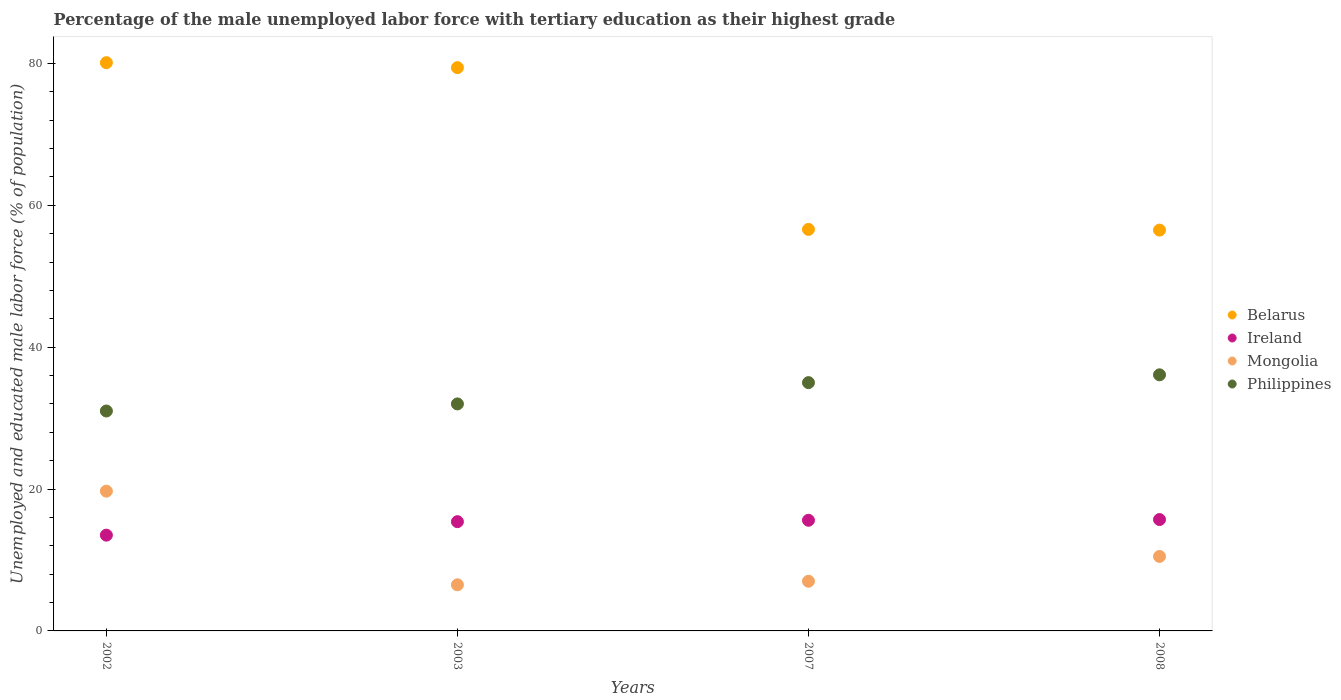Across all years, what is the maximum percentage of the unemployed male labor force with tertiary education in Ireland?
Provide a short and direct response. 15.7. Across all years, what is the minimum percentage of the unemployed male labor force with tertiary education in Belarus?
Offer a very short reply. 56.5. In which year was the percentage of the unemployed male labor force with tertiary education in Mongolia maximum?
Offer a terse response. 2002. In which year was the percentage of the unemployed male labor force with tertiary education in Ireland minimum?
Your answer should be very brief. 2002. What is the total percentage of the unemployed male labor force with tertiary education in Ireland in the graph?
Your answer should be compact. 60.2. What is the difference between the percentage of the unemployed male labor force with tertiary education in Mongolia in 2002 and that in 2003?
Offer a very short reply. 13.2. What is the difference between the percentage of the unemployed male labor force with tertiary education in Mongolia in 2002 and the percentage of the unemployed male labor force with tertiary education in Belarus in 2007?
Provide a short and direct response. -36.9. What is the average percentage of the unemployed male labor force with tertiary education in Philippines per year?
Give a very brief answer. 33.52. In the year 2003, what is the difference between the percentage of the unemployed male labor force with tertiary education in Mongolia and percentage of the unemployed male labor force with tertiary education in Philippines?
Give a very brief answer. -25.5. What is the ratio of the percentage of the unemployed male labor force with tertiary education in Belarus in 2002 to that in 2003?
Ensure brevity in your answer.  1.01. Is the percentage of the unemployed male labor force with tertiary education in Philippines in 2002 less than that in 2008?
Your answer should be very brief. Yes. Is the difference between the percentage of the unemployed male labor force with tertiary education in Mongolia in 2003 and 2007 greater than the difference between the percentage of the unemployed male labor force with tertiary education in Philippines in 2003 and 2007?
Make the answer very short. Yes. What is the difference between the highest and the second highest percentage of the unemployed male labor force with tertiary education in Belarus?
Make the answer very short. 0.7. What is the difference between the highest and the lowest percentage of the unemployed male labor force with tertiary education in Philippines?
Ensure brevity in your answer.  5.1. Is it the case that in every year, the sum of the percentage of the unemployed male labor force with tertiary education in Ireland and percentage of the unemployed male labor force with tertiary education in Belarus  is greater than the sum of percentage of the unemployed male labor force with tertiary education in Mongolia and percentage of the unemployed male labor force with tertiary education in Philippines?
Make the answer very short. Yes. Is it the case that in every year, the sum of the percentage of the unemployed male labor force with tertiary education in Philippines and percentage of the unemployed male labor force with tertiary education in Belarus  is greater than the percentage of the unemployed male labor force with tertiary education in Ireland?
Provide a short and direct response. Yes. Is the percentage of the unemployed male labor force with tertiary education in Philippines strictly greater than the percentage of the unemployed male labor force with tertiary education in Mongolia over the years?
Keep it short and to the point. Yes. Are the values on the major ticks of Y-axis written in scientific E-notation?
Keep it short and to the point. No. Does the graph contain any zero values?
Make the answer very short. No. How many legend labels are there?
Your answer should be very brief. 4. How are the legend labels stacked?
Offer a very short reply. Vertical. What is the title of the graph?
Your answer should be compact. Percentage of the male unemployed labor force with tertiary education as their highest grade. Does "Dominican Republic" appear as one of the legend labels in the graph?
Provide a succinct answer. No. What is the label or title of the Y-axis?
Your answer should be compact. Unemployed and educated male labor force (% of population). What is the Unemployed and educated male labor force (% of population) in Belarus in 2002?
Offer a terse response. 80.1. What is the Unemployed and educated male labor force (% of population) of Ireland in 2002?
Provide a short and direct response. 13.5. What is the Unemployed and educated male labor force (% of population) in Mongolia in 2002?
Provide a succinct answer. 19.7. What is the Unemployed and educated male labor force (% of population) in Belarus in 2003?
Make the answer very short. 79.4. What is the Unemployed and educated male labor force (% of population) in Ireland in 2003?
Keep it short and to the point. 15.4. What is the Unemployed and educated male labor force (% of population) of Mongolia in 2003?
Give a very brief answer. 6.5. What is the Unemployed and educated male labor force (% of population) of Philippines in 2003?
Your response must be concise. 32. What is the Unemployed and educated male labor force (% of population) in Belarus in 2007?
Provide a short and direct response. 56.6. What is the Unemployed and educated male labor force (% of population) of Ireland in 2007?
Provide a short and direct response. 15.6. What is the Unemployed and educated male labor force (% of population) of Philippines in 2007?
Give a very brief answer. 35. What is the Unemployed and educated male labor force (% of population) in Belarus in 2008?
Your response must be concise. 56.5. What is the Unemployed and educated male labor force (% of population) of Ireland in 2008?
Your answer should be very brief. 15.7. What is the Unemployed and educated male labor force (% of population) in Philippines in 2008?
Ensure brevity in your answer.  36.1. Across all years, what is the maximum Unemployed and educated male labor force (% of population) of Belarus?
Give a very brief answer. 80.1. Across all years, what is the maximum Unemployed and educated male labor force (% of population) in Ireland?
Your answer should be compact. 15.7. Across all years, what is the maximum Unemployed and educated male labor force (% of population) of Mongolia?
Make the answer very short. 19.7. Across all years, what is the maximum Unemployed and educated male labor force (% of population) of Philippines?
Give a very brief answer. 36.1. Across all years, what is the minimum Unemployed and educated male labor force (% of population) in Belarus?
Offer a terse response. 56.5. Across all years, what is the minimum Unemployed and educated male labor force (% of population) in Mongolia?
Your answer should be compact. 6.5. What is the total Unemployed and educated male labor force (% of population) in Belarus in the graph?
Keep it short and to the point. 272.6. What is the total Unemployed and educated male labor force (% of population) of Ireland in the graph?
Make the answer very short. 60.2. What is the total Unemployed and educated male labor force (% of population) of Mongolia in the graph?
Provide a short and direct response. 43.7. What is the total Unemployed and educated male labor force (% of population) of Philippines in the graph?
Make the answer very short. 134.1. What is the difference between the Unemployed and educated male labor force (% of population) of Belarus in 2002 and that in 2003?
Offer a terse response. 0.7. What is the difference between the Unemployed and educated male labor force (% of population) of Ireland in 2002 and that in 2003?
Your answer should be very brief. -1.9. What is the difference between the Unemployed and educated male labor force (% of population) in Mongolia in 2002 and that in 2003?
Ensure brevity in your answer.  13.2. What is the difference between the Unemployed and educated male labor force (% of population) in Philippines in 2002 and that in 2003?
Your answer should be very brief. -1. What is the difference between the Unemployed and educated male labor force (% of population) in Belarus in 2002 and that in 2007?
Offer a terse response. 23.5. What is the difference between the Unemployed and educated male labor force (% of population) in Ireland in 2002 and that in 2007?
Provide a succinct answer. -2.1. What is the difference between the Unemployed and educated male labor force (% of population) of Mongolia in 2002 and that in 2007?
Offer a terse response. 12.7. What is the difference between the Unemployed and educated male labor force (% of population) of Belarus in 2002 and that in 2008?
Your answer should be compact. 23.6. What is the difference between the Unemployed and educated male labor force (% of population) of Philippines in 2002 and that in 2008?
Offer a terse response. -5.1. What is the difference between the Unemployed and educated male labor force (% of population) of Belarus in 2003 and that in 2007?
Provide a succinct answer. 22.8. What is the difference between the Unemployed and educated male labor force (% of population) in Ireland in 2003 and that in 2007?
Offer a very short reply. -0.2. What is the difference between the Unemployed and educated male labor force (% of population) in Mongolia in 2003 and that in 2007?
Provide a succinct answer. -0.5. What is the difference between the Unemployed and educated male labor force (% of population) of Belarus in 2003 and that in 2008?
Your answer should be compact. 22.9. What is the difference between the Unemployed and educated male labor force (% of population) in Ireland in 2003 and that in 2008?
Ensure brevity in your answer.  -0.3. What is the difference between the Unemployed and educated male labor force (% of population) in Mongolia in 2003 and that in 2008?
Your answer should be compact. -4. What is the difference between the Unemployed and educated male labor force (% of population) of Belarus in 2007 and that in 2008?
Provide a short and direct response. 0.1. What is the difference between the Unemployed and educated male labor force (% of population) of Belarus in 2002 and the Unemployed and educated male labor force (% of population) of Ireland in 2003?
Your answer should be compact. 64.7. What is the difference between the Unemployed and educated male labor force (% of population) of Belarus in 2002 and the Unemployed and educated male labor force (% of population) of Mongolia in 2003?
Make the answer very short. 73.6. What is the difference between the Unemployed and educated male labor force (% of population) of Belarus in 2002 and the Unemployed and educated male labor force (% of population) of Philippines in 2003?
Your answer should be very brief. 48.1. What is the difference between the Unemployed and educated male labor force (% of population) in Ireland in 2002 and the Unemployed and educated male labor force (% of population) in Mongolia in 2003?
Keep it short and to the point. 7. What is the difference between the Unemployed and educated male labor force (% of population) in Ireland in 2002 and the Unemployed and educated male labor force (% of population) in Philippines in 2003?
Make the answer very short. -18.5. What is the difference between the Unemployed and educated male labor force (% of population) in Belarus in 2002 and the Unemployed and educated male labor force (% of population) in Ireland in 2007?
Offer a terse response. 64.5. What is the difference between the Unemployed and educated male labor force (% of population) of Belarus in 2002 and the Unemployed and educated male labor force (% of population) of Mongolia in 2007?
Provide a succinct answer. 73.1. What is the difference between the Unemployed and educated male labor force (% of population) of Belarus in 2002 and the Unemployed and educated male labor force (% of population) of Philippines in 2007?
Your response must be concise. 45.1. What is the difference between the Unemployed and educated male labor force (% of population) of Ireland in 2002 and the Unemployed and educated male labor force (% of population) of Philippines in 2007?
Provide a succinct answer. -21.5. What is the difference between the Unemployed and educated male labor force (% of population) of Mongolia in 2002 and the Unemployed and educated male labor force (% of population) of Philippines in 2007?
Your answer should be very brief. -15.3. What is the difference between the Unemployed and educated male labor force (% of population) of Belarus in 2002 and the Unemployed and educated male labor force (% of population) of Ireland in 2008?
Ensure brevity in your answer.  64.4. What is the difference between the Unemployed and educated male labor force (% of population) in Belarus in 2002 and the Unemployed and educated male labor force (% of population) in Mongolia in 2008?
Your answer should be compact. 69.6. What is the difference between the Unemployed and educated male labor force (% of population) in Belarus in 2002 and the Unemployed and educated male labor force (% of population) in Philippines in 2008?
Provide a short and direct response. 44. What is the difference between the Unemployed and educated male labor force (% of population) of Ireland in 2002 and the Unemployed and educated male labor force (% of population) of Philippines in 2008?
Give a very brief answer. -22.6. What is the difference between the Unemployed and educated male labor force (% of population) of Mongolia in 2002 and the Unemployed and educated male labor force (% of population) of Philippines in 2008?
Offer a terse response. -16.4. What is the difference between the Unemployed and educated male labor force (% of population) in Belarus in 2003 and the Unemployed and educated male labor force (% of population) in Ireland in 2007?
Provide a succinct answer. 63.8. What is the difference between the Unemployed and educated male labor force (% of population) of Belarus in 2003 and the Unemployed and educated male labor force (% of population) of Mongolia in 2007?
Your answer should be very brief. 72.4. What is the difference between the Unemployed and educated male labor force (% of population) of Belarus in 2003 and the Unemployed and educated male labor force (% of population) of Philippines in 2007?
Your answer should be compact. 44.4. What is the difference between the Unemployed and educated male labor force (% of population) in Ireland in 2003 and the Unemployed and educated male labor force (% of population) in Mongolia in 2007?
Your answer should be very brief. 8.4. What is the difference between the Unemployed and educated male labor force (% of population) in Ireland in 2003 and the Unemployed and educated male labor force (% of population) in Philippines in 2007?
Ensure brevity in your answer.  -19.6. What is the difference between the Unemployed and educated male labor force (% of population) in Mongolia in 2003 and the Unemployed and educated male labor force (% of population) in Philippines in 2007?
Ensure brevity in your answer.  -28.5. What is the difference between the Unemployed and educated male labor force (% of population) in Belarus in 2003 and the Unemployed and educated male labor force (% of population) in Ireland in 2008?
Keep it short and to the point. 63.7. What is the difference between the Unemployed and educated male labor force (% of population) in Belarus in 2003 and the Unemployed and educated male labor force (% of population) in Mongolia in 2008?
Offer a terse response. 68.9. What is the difference between the Unemployed and educated male labor force (% of population) in Belarus in 2003 and the Unemployed and educated male labor force (% of population) in Philippines in 2008?
Your response must be concise. 43.3. What is the difference between the Unemployed and educated male labor force (% of population) in Ireland in 2003 and the Unemployed and educated male labor force (% of population) in Philippines in 2008?
Your answer should be very brief. -20.7. What is the difference between the Unemployed and educated male labor force (% of population) of Mongolia in 2003 and the Unemployed and educated male labor force (% of population) of Philippines in 2008?
Your answer should be compact. -29.6. What is the difference between the Unemployed and educated male labor force (% of population) of Belarus in 2007 and the Unemployed and educated male labor force (% of population) of Ireland in 2008?
Offer a terse response. 40.9. What is the difference between the Unemployed and educated male labor force (% of population) of Belarus in 2007 and the Unemployed and educated male labor force (% of population) of Mongolia in 2008?
Ensure brevity in your answer.  46.1. What is the difference between the Unemployed and educated male labor force (% of population) of Belarus in 2007 and the Unemployed and educated male labor force (% of population) of Philippines in 2008?
Provide a short and direct response. 20.5. What is the difference between the Unemployed and educated male labor force (% of population) of Ireland in 2007 and the Unemployed and educated male labor force (% of population) of Mongolia in 2008?
Your answer should be very brief. 5.1. What is the difference between the Unemployed and educated male labor force (% of population) of Ireland in 2007 and the Unemployed and educated male labor force (% of population) of Philippines in 2008?
Your answer should be very brief. -20.5. What is the difference between the Unemployed and educated male labor force (% of population) in Mongolia in 2007 and the Unemployed and educated male labor force (% of population) in Philippines in 2008?
Offer a very short reply. -29.1. What is the average Unemployed and educated male labor force (% of population) in Belarus per year?
Offer a terse response. 68.15. What is the average Unemployed and educated male labor force (% of population) in Ireland per year?
Provide a short and direct response. 15.05. What is the average Unemployed and educated male labor force (% of population) of Mongolia per year?
Make the answer very short. 10.93. What is the average Unemployed and educated male labor force (% of population) in Philippines per year?
Give a very brief answer. 33.52. In the year 2002, what is the difference between the Unemployed and educated male labor force (% of population) in Belarus and Unemployed and educated male labor force (% of population) in Ireland?
Your answer should be very brief. 66.6. In the year 2002, what is the difference between the Unemployed and educated male labor force (% of population) in Belarus and Unemployed and educated male labor force (% of population) in Mongolia?
Your response must be concise. 60.4. In the year 2002, what is the difference between the Unemployed and educated male labor force (% of population) in Belarus and Unemployed and educated male labor force (% of population) in Philippines?
Offer a very short reply. 49.1. In the year 2002, what is the difference between the Unemployed and educated male labor force (% of population) of Ireland and Unemployed and educated male labor force (% of population) of Philippines?
Your answer should be compact. -17.5. In the year 2003, what is the difference between the Unemployed and educated male labor force (% of population) in Belarus and Unemployed and educated male labor force (% of population) in Ireland?
Your response must be concise. 64. In the year 2003, what is the difference between the Unemployed and educated male labor force (% of population) of Belarus and Unemployed and educated male labor force (% of population) of Mongolia?
Your answer should be compact. 72.9. In the year 2003, what is the difference between the Unemployed and educated male labor force (% of population) in Belarus and Unemployed and educated male labor force (% of population) in Philippines?
Your response must be concise. 47.4. In the year 2003, what is the difference between the Unemployed and educated male labor force (% of population) in Ireland and Unemployed and educated male labor force (% of population) in Philippines?
Provide a succinct answer. -16.6. In the year 2003, what is the difference between the Unemployed and educated male labor force (% of population) of Mongolia and Unemployed and educated male labor force (% of population) of Philippines?
Make the answer very short. -25.5. In the year 2007, what is the difference between the Unemployed and educated male labor force (% of population) of Belarus and Unemployed and educated male labor force (% of population) of Ireland?
Give a very brief answer. 41. In the year 2007, what is the difference between the Unemployed and educated male labor force (% of population) in Belarus and Unemployed and educated male labor force (% of population) in Mongolia?
Your response must be concise. 49.6. In the year 2007, what is the difference between the Unemployed and educated male labor force (% of population) of Belarus and Unemployed and educated male labor force (% of population) of Philippines?
Provide a succinct answer. 21.6. In the year 2007, what is the difference between the Unemployed and educated male labor force (% of population) in Ireland and Unemployed and educated male labor force (% of population) in Mongolia?
Your answer should be very brief. 8.6. In the year 2007, what is the difference between the Unemployed and educated male labor force (% of population) of Ireland and Unemployed and educated male labor force (% of population) of Philippines?
Make the answer very short. -19.4. In the year 2008, what is the difference between the Unemployed and educated male labor force (% of population) in Belarus and Unemployed and educated male labor force (% of population) in Ireland?
Provide a succinct answer. 40.8. In the year 2008, what is the difference between the Unemployed and educated male labor force (% of population) in Belarus and Unemployed and educated male labor force (% of population) in Philippines?
Offer a terse response. 20.4. In the year 2008, what is the difference between the Unemployed and educated male labor force (% of population) in Ireland and Unemployed and educated male labor force (% of population) in Philippines?
Keep it short and to the point. -20.4. In the year 2008, what is the difference between the Unemployed and educated male labor force (% of population) of Mongolia and Unemployed and educated male labor force (% of population) of Philippines?
Ensure brevity in your answer.  -25.6. What is the ratio of the Unemployed and educated male labor force (% of population) of Belarus in 2002 to that in 2003?
Your answer should be compact. 1.01. What is the ratio of the Unemployed and educated male labor force (% of population) of Ireland in 2002 to that in 2003?
Provide a succinct answer. 0.88. What is the ratio of the Unemployed and educated male labor force (% of population) of Mongolia in 2002 to that in 2003?
Keep it short and to the point. 3.03. What is the ratio of the Unemployed and educated male labor force (% of population) in Philippines in 2002 to that in 2003?
Offer a terse response. 0.97. What is the ratio of the Unemployed and educated male labor force (% of population) of Belarus in 2002 to that in 2007?
Ensure brevity in your answer.  1.42. What is the ratio of the Unemployed and educated male labor force (% of population) in Ireland in 2002 to that in 2007?
Provide a short and direct response. 0.87. What is the ratio of the Unemployed and educated male labor force (% of population) in Mongolia in 2002 to that in 2007?
Make the answer very short. 2.81. What is the ratio of the Unemployed and educated male labor force (% of population) of Philippines in 2002 to that in 2007?
Keep it short and to the point. 0.89. What is the ratio of the Unemployed and educated male labor force (% of population) of Belarus in 2002 to that in 2008?
Ensure brevity in your answer.  1.42. What is the ratio of the Unemployed and educated male labor force (% of population) of Ireland in 2002 to that in 2008?
Ensure brevity in your answer.  0.86. What is the ratio of the Unemployed and educated male labor force (% of population) of Mongolia in 2002 to that in 2008?
Provide a short and direct response. 1.88. What is the ratio of the Unemployed and educated male labor force (% of population) in Philippines in 2002 to that in 2008?
Give a very brief answer. 0.86. What is the ratio of the Unemployed and educated male labor force (% of population) of Belarus in 2003 to that in 2007?
Provide a succinct answer. 1.4. What is the ratio of the Unemployed and educated male labor force (% of population) of Ireland in 2003 to that in 2007?
Your response must be concise. 0.99. What is the ratio of the Unemployed and educated male labor force (% of population) of Philippines in 2003 to that in 2007?
Provide a succinct answer. 0.91. What is the ratio of the Unemployed and educated male labor force (% of population) in Belarus in 2003 to that in 2008?
Make the answer very short. 1.41. What is the ratio of the Unemployed and educated male labor force (% of population) of Ireland in 2003 to that in 2008?
Offer a very short reply. 0.98. What is the ratio of the Unemployed and educated male labor force (% of population) in Mongolia in 2003 to that in 2008?
Your response must be concise. 0.62. What is the ratio of the Unemployed and educated male labor force (% of population) in Philippines in 2003 to that in 2008?
Offer a terse response. 0.89. What is the ratio of the Unemployed and educated male labor force (% of population) in Belarus in 2007 to that in 2008?
Provide a short and direct response. 1. What is the ratio of the Unemployed and educated male labor force (% of population) in Ireland in 2007 to that in 2008?
Provide a succinct answer. 0.99. What is the ratio of the Unemployed and educated male labor force (% of population) in Mongolia in 2007 to that in 2008?
Offer a terse response. 0.67. What is the ratio of the Unemployed and educated male labor force (% of population) in Philippines in 2007 to that in 2008?
Your response must be concise. 0.97. What is the difference between the highest and the second highest Unemployed and educated male labor force (% of population) of Belarus?
Ensure brevity in your answer.  0.7. What is the difference between the highest and the second highest Unemployed and educated male labor force (% of population) in Mongolia?
Your answer should be very brief. 9.2. What is the difference between the highest and the second highest Unemployed and educated male labor force (% of population) in Philippines?
Offer a terse response. 1.1. What is the difference between the highest and the lowest Unemployed and educated male labor force (% of population) of Belarus?
Ensure brevity in your answer.  23.6. What is the difference between the highest and the lowest Unemployed and educated male labor force (% of population) in Mongolia?
Your answer should be very brief. 13.2. What is the difference between the highest and the lowest Unemployed and educated male labor force (% of population) of Philippines?
Offer a terse response. 5.1. 